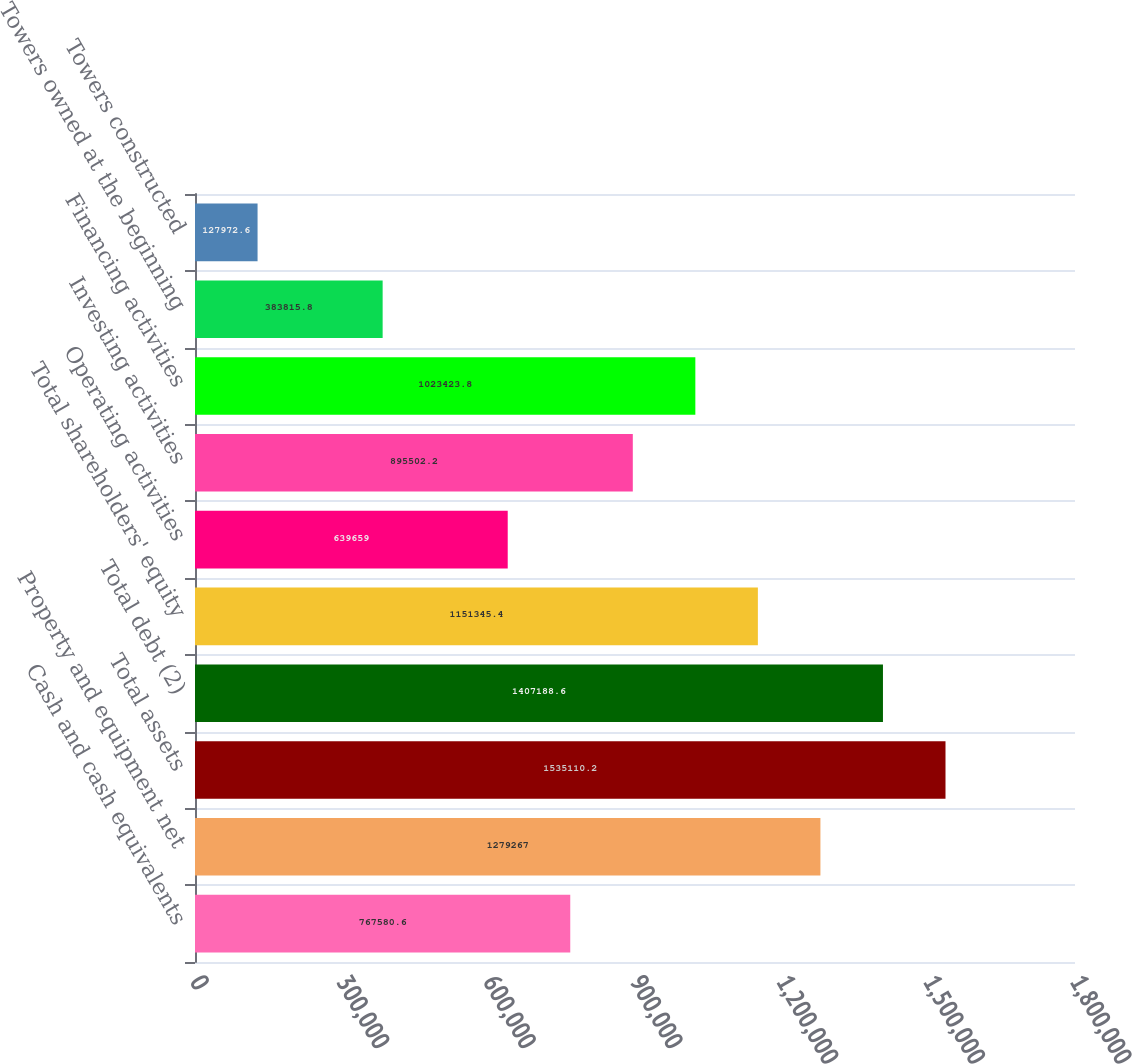Convert chart. <chart><loc_0><loc_0><loc_500><loc_500><bar_chart><fcel>Cash and cash equivalents<fcel>Property and equipment net<fcel>Total assets<fcel>Total debt (2)<fcel>Total shareholders' equity<fcel>Operating activities<fcel>Investing activities<fcel>Financing activities<fcel>Towers owned at the beginning<fcel>Towers constructed<nl><fcel>767581<fcel>1.27927e+06<fcel>1.53511e+06<fcel>1.40719e+06<fcel>1.15135e+06<fcel>639659<fcel>895502<fcel>1.02342e+06<fcel>383816<fcel>127973<nl></chart> 